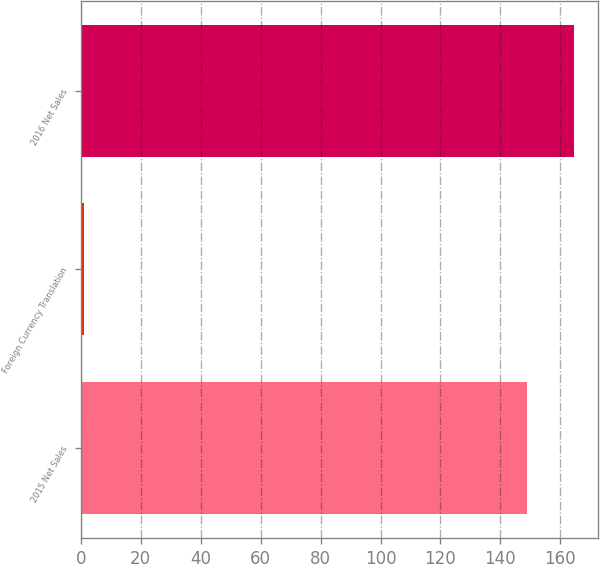<chart> <loc_0><loc_0><loc_500><loc_500><bar_chart><fcel>2015 Net Sales<fcel>Foreign Currency Translation<fcel>2016 Net Sales<nl><fcel>149<fcel>1<fcel>164.5<nl></chart> 